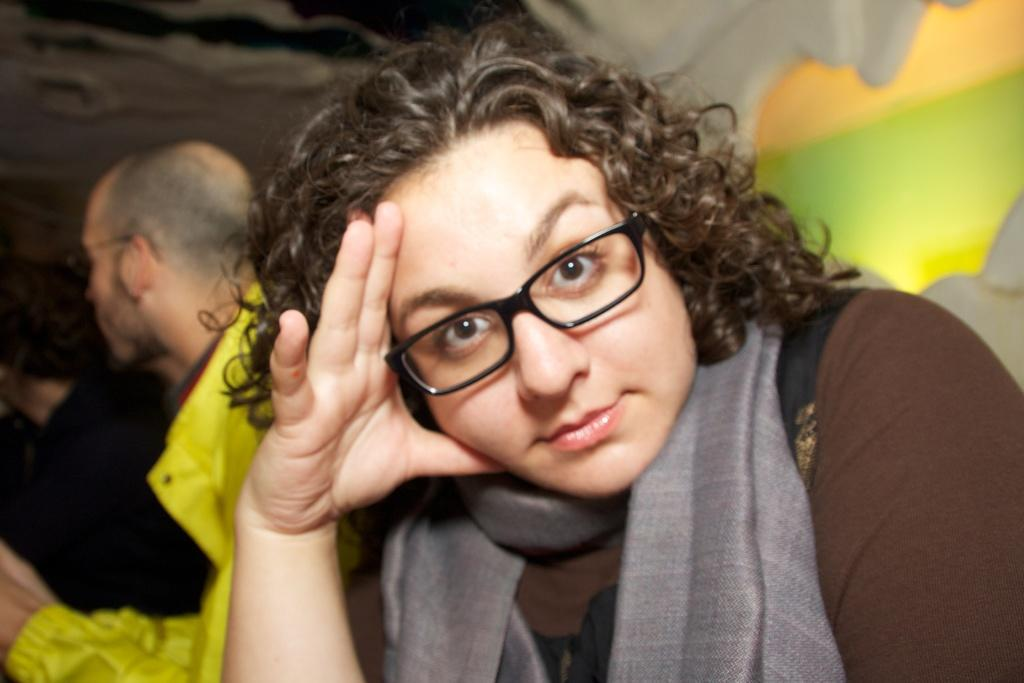What is the person in the image wearing on their face? The person in the image is wearing glasses. How many other people are present in the image? There are two other people in the image. What can be seen in the background of the image? There is a wall and a light in the background of the image. What type of rhythm does the organization in the image follow? There is no organization or rhythm present in the image; it is a scene with people and a background. 